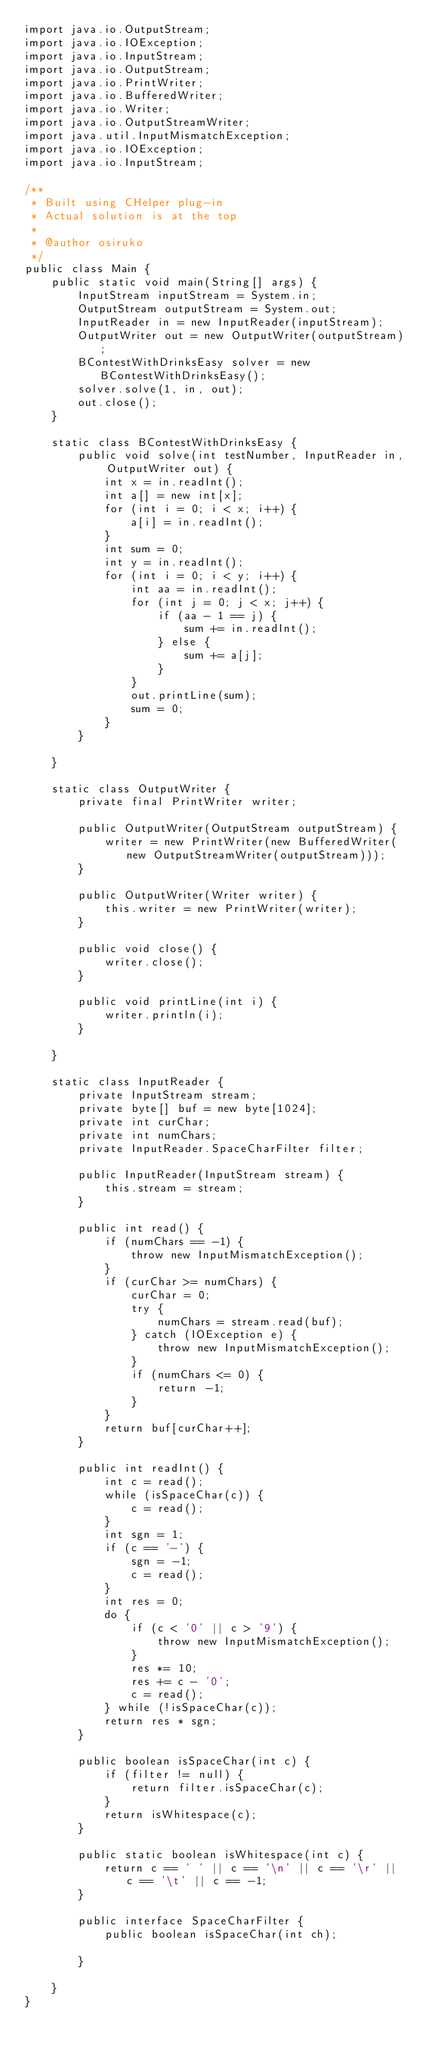<code> <loc_0><loc_0><loc_500><loc_500><_Java_>import java.io.OutputStream;
import java.io.IOException;
import java.io.InputStream;
import java.io.OutputStream;
import java.io.PrintWriter;
import java.io.BufferedWriter;
import java.io.Writer;
import java.io.OutputStreamWriter;
import java.util.InputMismatchException;
import java.io.IOException;
import java.io.InputStream;

/**
 * Built using CHelper plug-in
 * Actual solution is at the top
 *
 * @author osiruko
 */
public class Main {
    public static void main(String[] args) {
        InputStream inputStream = System.in;
        OutputStream outputStream = System.out;
        InputReader in = new InputReader(inputStream);
        OutputWriter out = new OutputWriter(outputStream);
        BContestWithDrinksEasy solver = new BContestWithDrinksEasy();
        solver.solve(1, in, out);
        out.close();
    }

    static class BContestWithDrinksEasy {
        public void solve(int testNumber, InputReader in, OutputWriter out) {
            int x = in.readInt();
            int a[] = new int[x];
            for (int i = 0; i < x; i++) {
                a[i] = in.readInt();
            }
            int sum = 0;
            int y = in.readInt();
            for (int i = 0; i < y; i++) {
                int aa = in.readInt();
                for (int j = 0; j < x; j++) {
                    if (aa - 1 == j) {
                        sum += in.readInt();
                    } else {
                        sum += a[j];
                    }
                }
                out.printLine(sum);
                sum = 0;
            }
        }

    }

    static class OutputWriter {
        private final PrintWriter writer;

        public OutputWriter(OutputStream outputStream) {
            writer = new PrintWriter(new BufferedWriter(new OutputStreamWriter(outputStream)));
        }

        public OutputWriter(Writer writer) {
            this.writer = new PrintWriter(writer);
        }

        public void close() {
            writer.close();
        }

        public void printLine(int i) {
            writer.println(i);
        }

    }

    static class InputReader {
        private InputStream stream;
        private byte[] buf = new byte[1024];
        private int curChar;
        private int numChars;
        private InputReader.SpaceCharFilter filter;

        public InputReader(InputStream stream) {
            this.stream = stream;
        }

        public int read() {
            if (numChars == -1) {
                throw new InputMismatchException();
            }
            if (curChar >= numChars) {
                curChar = 0;
                try {
                    numChars = stream.read(buf);
                } catch (IOException e) {
                    throw new InputMismatchException();
                }
                if (numChars <= 0) {
                    return -1;
                }
            }
            return buf[curChar++];
        }

        public int readInt() {
            int c = read();
            while (isSpaceChar(c)) {
                c = read();
            }
            int sgn = 1;
            if (c == '-') {
                sgn = -1;
                c = read();
            }
            int res = 0;
            do {
                if (c < '0' || c > '9') {
                    throw new InputMismatchException();
                }
                res *= 10;
                res += c - '0';
                c = read();
            } while (!isSpaceChar(c));
            return res * sgn;
        }

        public boolean isSpaceChar(int c) {
            if (filter != null) {
                return filter.isSpaceChar(c);
            }
            return isWhitespace(c);
        }

        public static boolean isWhitespace(int c) {
            return c == ' ' || c == '\n' || c == '\r' || c == '\t' || c == -1;
        }

        public interface SpaceCharFilter {
            public boolean isSpaceChar(int ch);

        }

    }
}

</code> 